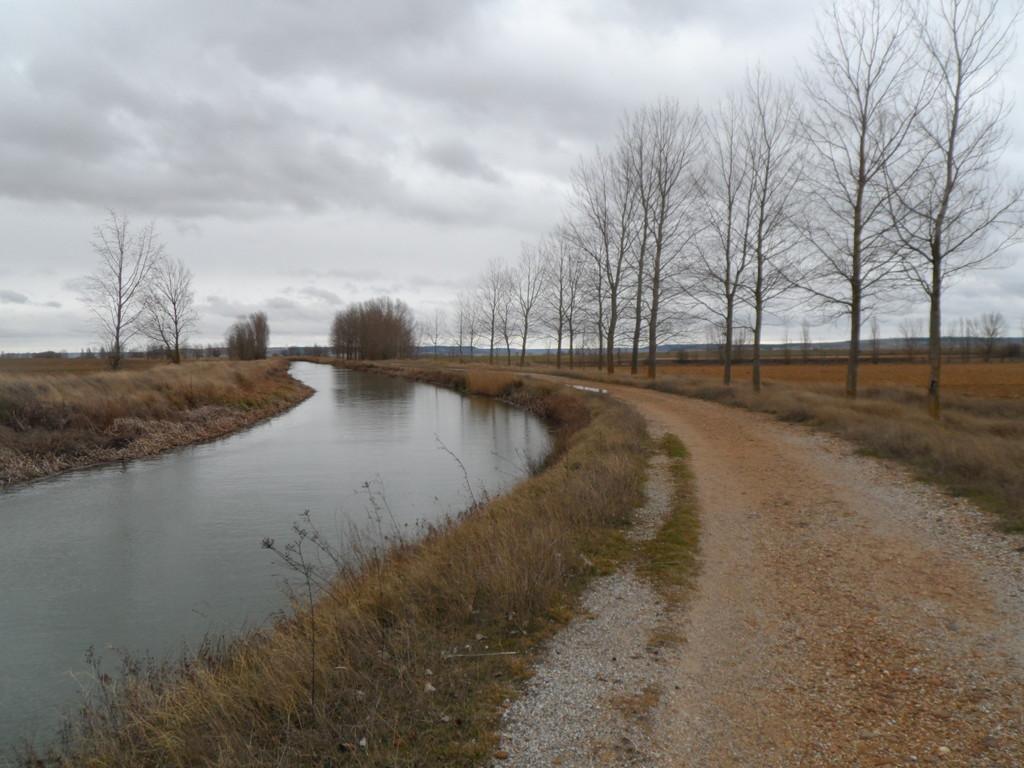Please provide a concise description of this image. This picture is clicked outside the city. On the left there is a water body and we can see the grass. In the background there is a sky, trees and plants. 